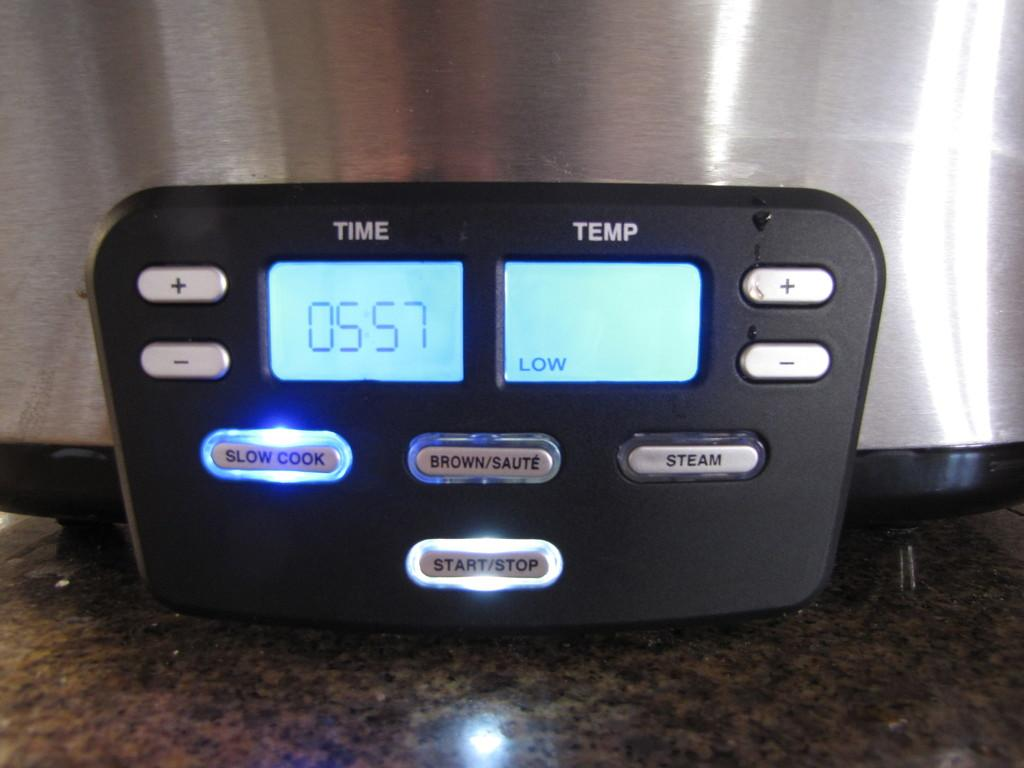<image>
Offer a succinct explanation of the picture presented. A cookware display shows that it is cooking at low temperature. 